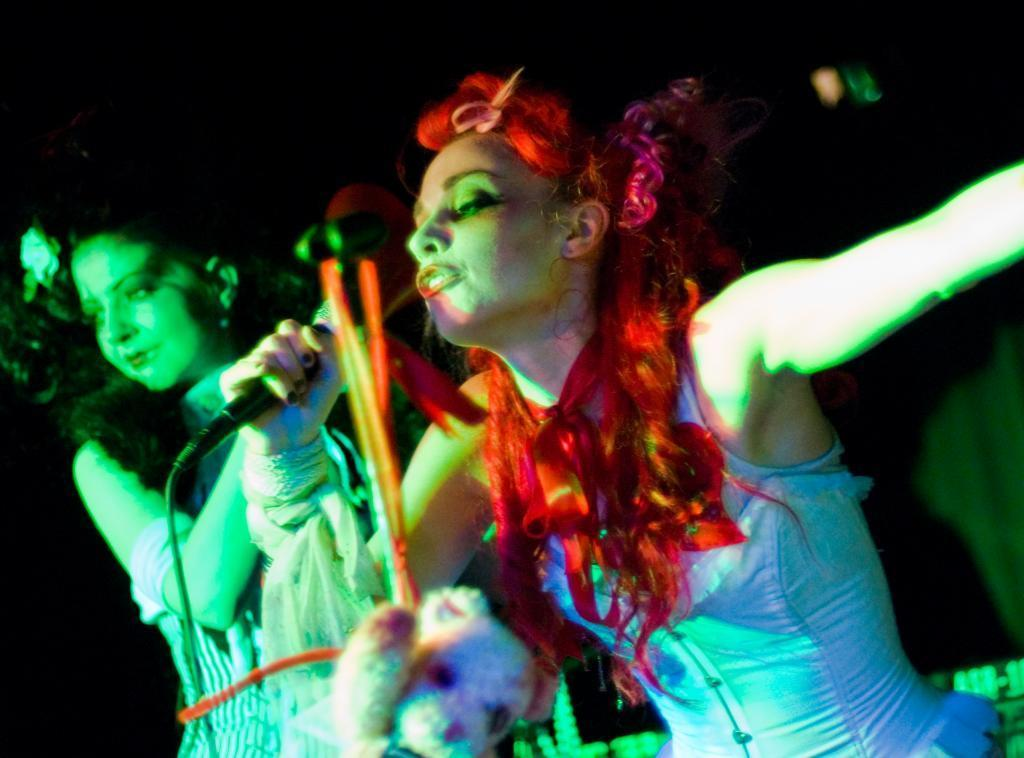What is the woman in the image holding? The woman is holding a microphone in the image. What can be seen at the bottom of the image? There is a toy at the bottom of the image. Can you describe the woman on the left side of the image? There is a woman on the left side of the image. How would you describe the background of the image? The background of the image is blurry. What type of needle is being used by the woman in the image? There is no needle present in the image; the woman is holding a microphone. What is the condition of the popcorn in the image? There is no popcorn present in the image. 